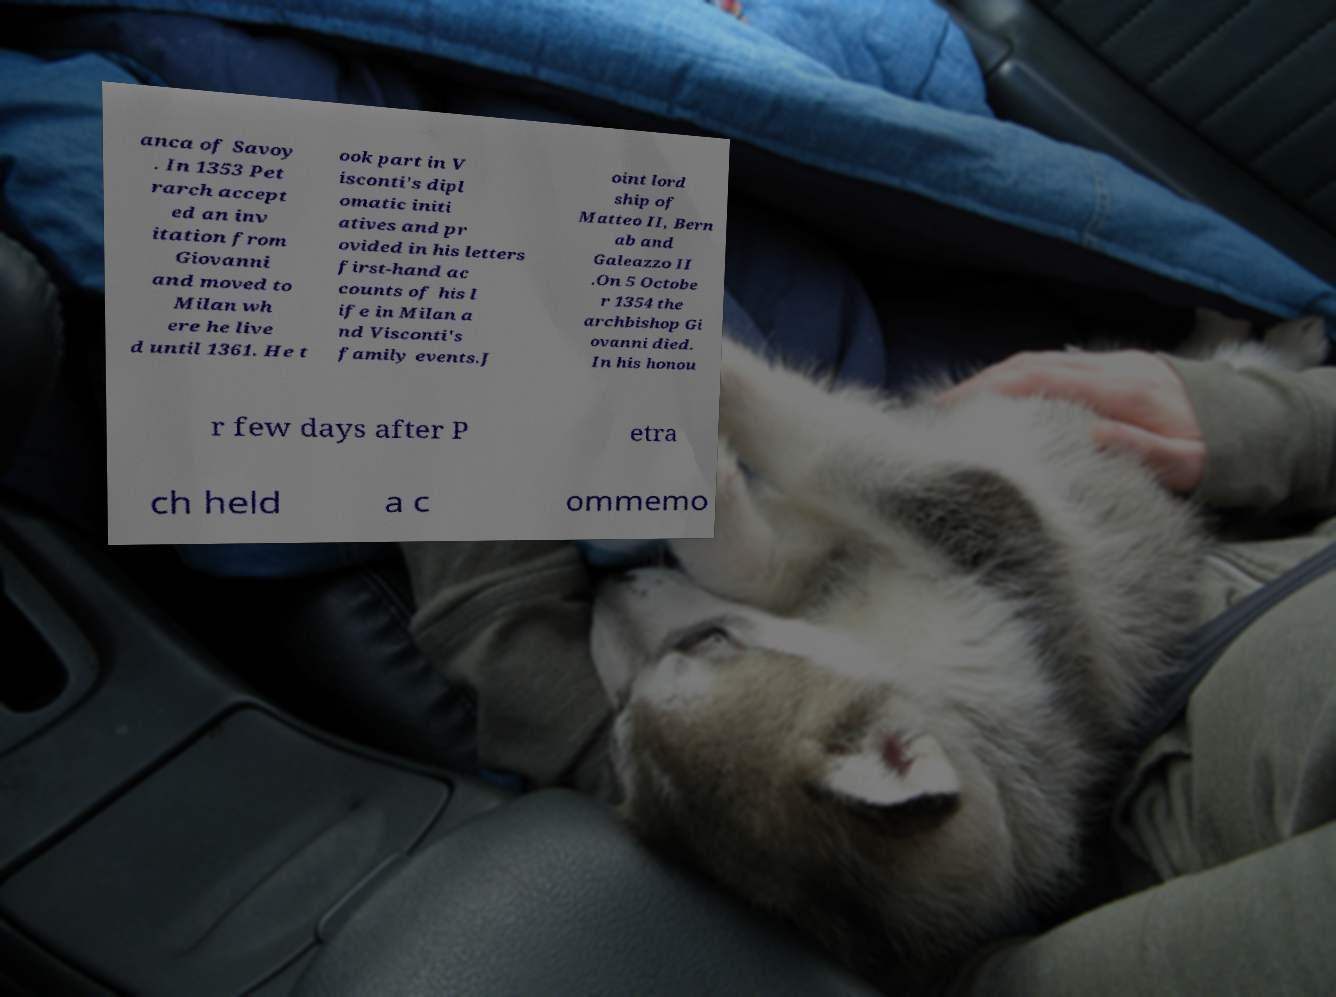Can you accurately transcribe the text from the provided image for me? anca of Savoy . In 1353 Pet rarch accept ed an inv itation from Giovanni and moved to Milan wh ere he live d until 1361. He t ook part in V isconti's dipl omatic initi atives and pr ovided in his letters first-hand ac counts of his l ife in Milan a nd Visconti's family events.J oint lord ship of Matteo II, Bern ab and Galeazzo II .On 5 Octobe r 1354 the archbishop Gi ovanni died. In his honou r few days after P etra ch held a c ommemo 